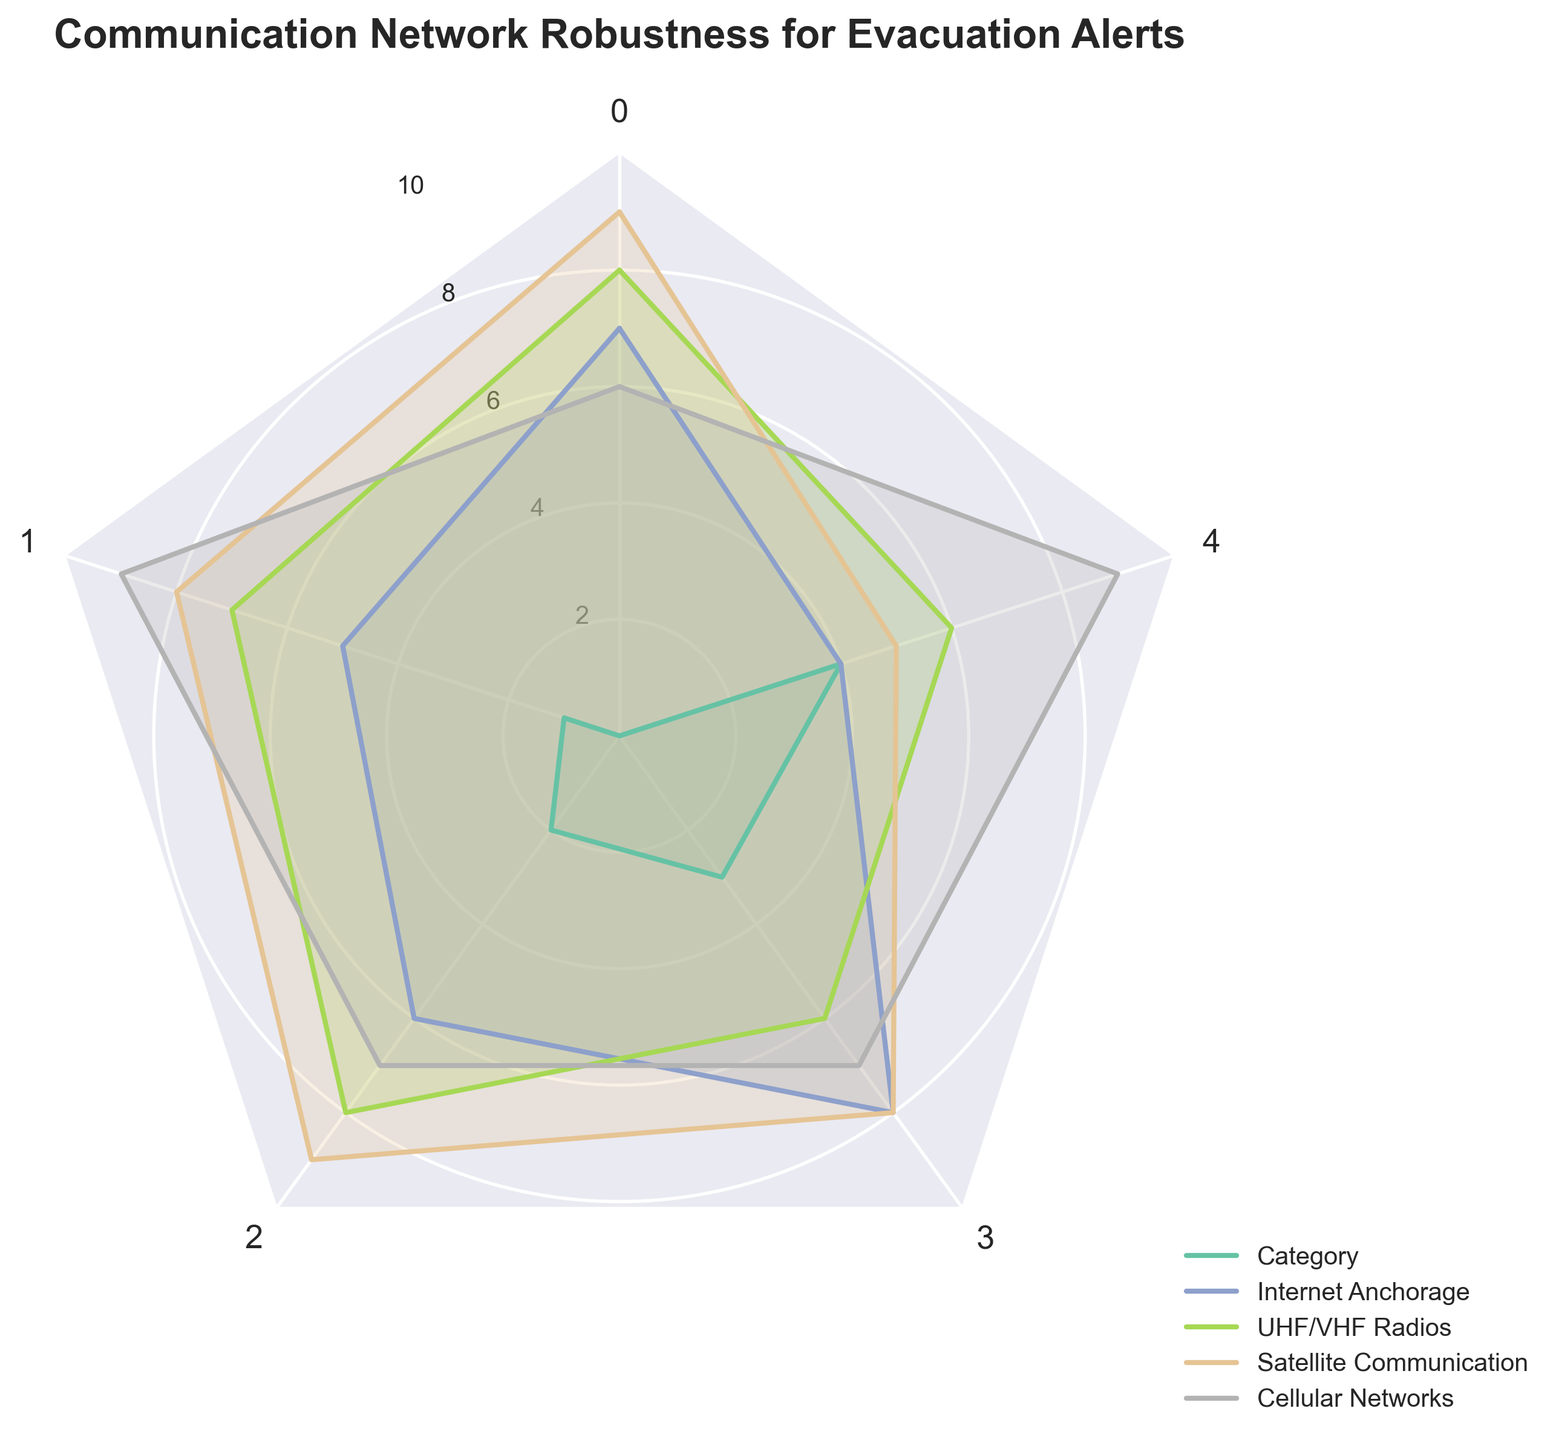How many categories are assessed in the radar chart? The radar chart shows five distinct categories being assessed for each group.
Answer: Five Which group has the highest reliability? The reliability values for each group are: Internet Anchorage: 7, UHF/VHF Radios: 8, Satellite Communication: 9, Cellular Networks: 6. Thus, Satellite Communication has the highest reliability.
Answer: Satellite Communication What is the average coverage score across all groups? The coverage scores are: Internet Anchorage: 5, UHF/VHF Radios: 7, Satellite Communication: 8, Cellular Networks: 9. (5+7+8+9)/4 = 7.25.
Answer: 7.25 Which group scores the lowest in public accessibility? The public accessibility scores are: Internet Anchorage: 4, UHF/VHF Radios: 6, Satellite Communication: 5, Cellular Networks: 9. Therefore, Internet Anchorage has the lowest score.
Answer: Internet Anchorage How does the speed of Internet Anchorage compare to UHF/VHF Radios? The speed score for Internet Anchorage is 8, while for UHF/VHF Radios it is 6. Therefore, Internet Anchorage has a higher speed score.
Answer: Internet Anchorage has a higher speed score Which category shows the greatest variance among all groups? Evaluating the range of scores for each category: Reliability: 9-6=3, Coverage: 9-5=4, Redundancy: 9-6=3, Speed: 8-6=2, Public Accessibility: 9-4=5. Public Accessibility has the greatest variance, with a range of 5.
Answer: Public Accessibility What is the difference in redundancy scores between Satellite Communication and Cellular Networks? The redundancy scores are: Satellite Communication: 9, Cellular Networks: 7. The difference is 9-7 = 2.
Answer: 2 Are there any groups that scored a perfect score in any category? By examining the scores, no group has a score of 10 in any category.
Answer: No What is the average score for Cellular Networks across all categories? The scores for Cellular Networks are: Reliability: 6, Coverage: 9, Redundancy: 7, Speed: 7, Public Accessibility: 9. (6+9+7+7+9)/5 = 7.6.
Answer: 7.6 Which category has the lowest score for Satellite Communication? The scores for Satellite Communication are: Reliability: 9, Coverage: 8, Redundancy: 9, Speed: 8, Public Accessibility: 5. The lowest score is in Public Accessibility, with a score of 5.
Answer: Public Accessibility 